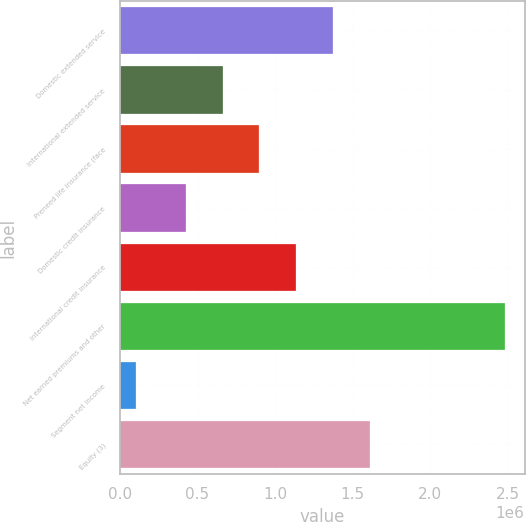Convert chart to OTSL. <chart><loc_0><loc_0><loc_500><loc_500><bar_chart><fcel>Domestic extended service<fcel>International extended service<fcel>Preneed life insurance (face<fcel>Domestic credit insurance<fcel>International credit insurance<fcel>Net earned premiums and other<fcel>Segment net income<fcel>Equity (3)<nl><fcel>1.37526e+06<fcel>660934<fcel>899044<fcel>422825<fcel>1.13715e+06<fcel>2.4843e+06<fcel>103206<fcel>1.61337e+06<nl></chart> 